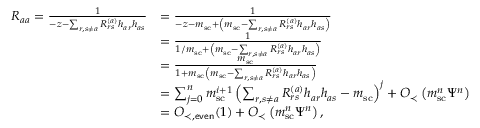Convert formula to latex. <formula><loc_0><loc_0><loc_500><loc_500>\begin{array} { r l } { R _ { a a } = \frac { 1 } { - z - \sum _ { r , s \neq a } R _ { r s } ^ { ( a ) } h _ { a r } h _ { a s } } } & { = \frac { 1 } { - z - m _ { s c } + \left ( m _ { s c } - \sum _ { r , s \neq a } R _ { r s } ^ { ( a ) } h _ { a r } h _ { a s } \right ) } } \\ & { = \frac { 1 } { 1 / m _ { s c } + \left ( m _ { s c } - \sum _ { r , s \neq a } R _ { r s } ^ { ( a ) } h _ { a r } h _ { a s } \right ) } } \\ & { = \frac { m _ { s c } } { 1 + m _ { s c } \left ( m _ { s c } - \sum _ { r , s \neq a } R _ { r s } ^ { ( a ) } h _ { a r } h _ { a s } \right ) } } \\ & { = \sum _ { j = 0 } ^ { n } m _ { s c } ^ { i + 1 } \left ( \sum _ { r , s \neq a } R _ { r s } ^ { ( a ) } h _ { a r } h _ { a s } - m _ { s c } \right ) ^ { j } + O _ { \prec } \left ( m _ { s c } ^ { n } \Psi ^ { n } \right ) } \\ & { = O _ { \prec , e v e n } ( 1 ) + O _ { \prec } \left ( m _ { s c } ^ { n } \Psi ^ { n } \right ) , } \end{array}</formula> 